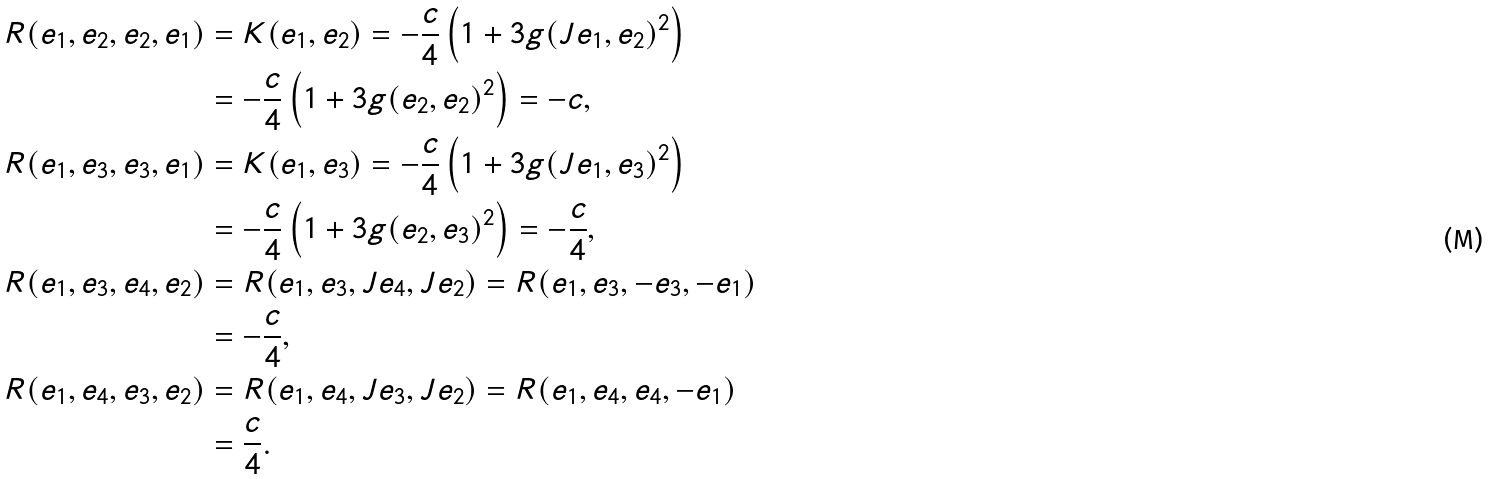Convert formula to latex. <formula><loc_0><loc_0><loc_500><loc_500>R ( e _ { 1 } , e _ { 2 } , e _ { 2 } , e _ { 1 } ) & = K ( e _ { 1 } , e _ { 2 } ) = - \frac { c } { 4 } \left ( 1 + 3 g ( J e _ { 1 } , e _ { 2 } ) ^ { 2 } \right ) \\ & = - \frac { c } { 4 } \left ( 1 + 3 g ( e _ { 2 } , e _ { 2 } ) ^ { 2 } \right ) = - c , \\ R ( e _ { 1 } , e _ { 3 } , e _ { 3 } , e _ { 1 } ) & = K ( e _ { 1 } , e _ { 3 } ) = - \frac { c } { 4 } \left ( 1 + 3 g ( J e _ { 1 } , e _ { 3 } ) ^ { 2 } \right ) \\ & = - \frac { c } { 4 } \left ( 1 + 3 g ( e _ { 2 } , e _ { 3 } ) ^ { 2 } \right ) = - \frac { c } { 4 } , \\ R ( e _ { 1 } , e _ { 3 } , e _ { 4 } , e _ { 2 } ) & = R ( e _ { 1 } , e _ { 3 } , J e _ { 4 } , J e _ { 2 } ) = R ( e _ { 1 } , e _ { 3 } , - e _ { 3 } , - e _ { 1 } ) \\ & = - \frac { c } { 4 } , \\ R ( e _ { 1 } , e _ { 4 } , e _ { 3 } , e _ { 2 } ) & = R ( e _ { 1 } , e _ { 4 } , J e _ { 3 } , J e _ { 2 } ) = R ( e _ { 1 } , e _ { 4 } , e _ { 4 } , - e _ { 1 } ) \\ & = \frac { c } { 4 } .</formula> 